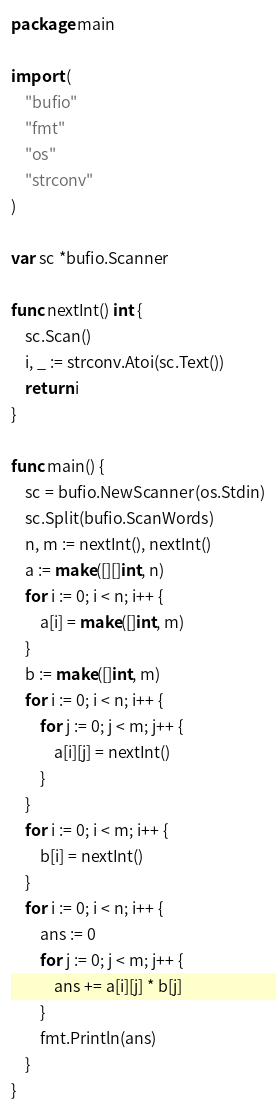Convert code to text. <code><loc_0><loc_0><loc_500><loc_500><_Go_>package main

import (
	"bufio"
	"fmt"
	"os"
	"strconv"
)

var sc *bufio.Scanner

func nextInt() int {
	sc.Scan()
	i, _ := strconv.Atoi(sc.Text())
	return i
}

func main() {
	sc = bufio.NewScanner(os.Stdin)
	sc.Split(bufio.ScanWords)
	n, m := nextInt(), nextInt()
	a := make([][]int, n)
	for i := 0; i < n; i++ {
		a[i] = make([]int, m)
	}
	b := make([]int, m)
	for i := 0; i < n; i++ {
		for j := 0; j < m; j++ {
			a[i][j] = nextInt()
		}
	}
	for i := 0; i < m; i++ {
		b[i] = nextInt()
	}
	for i := 0; i < n; i++ {
		ans := 0
		for j := 0; j < m; j++ {
			ans += a[i][j] * b[j]
		}
		fmt.Println(ans)
	}
}

</code> 